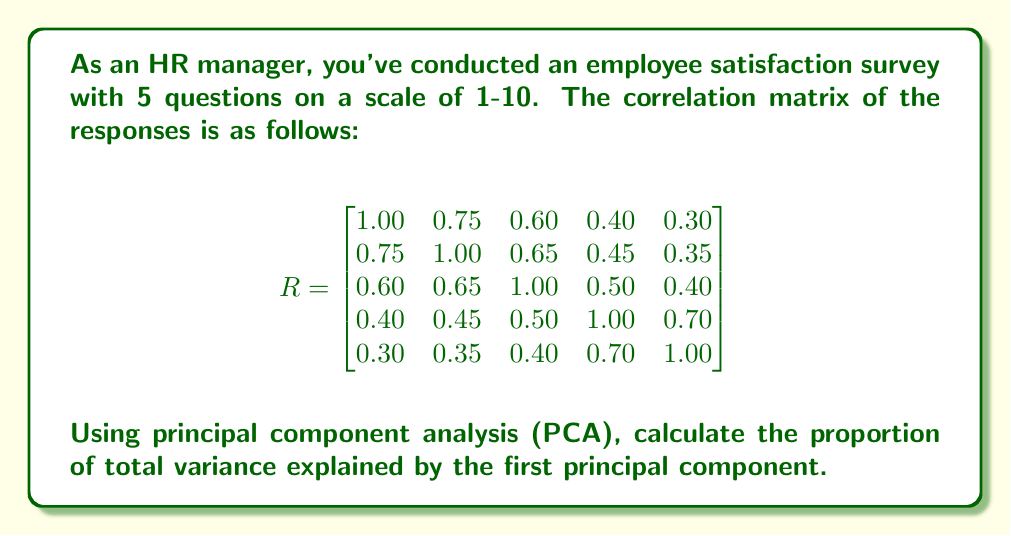Show me your answer to this math problem. To solve this problem, we'll follow these steps:

1) In PCA, the eigenvalues of the correlation matrix represent the variance explained by each principal component.

2) Calculate the eigenvalues of the correlation matrix R. The characteristic equation is:

   $\det(R - \lambda I) = 0$

   Solving this equation gives us the eigenvalues:
   $\lambda_1 = 2.9364, \lambda_2 = 1.0636, \lambda_3 = 0.5000, \lambda_4 = 0.3000, \lambda_5 = 0.2000$

3) The total variance is the sum of all eigenvalues:

   $\text{Total Variance} = \sum_{i=1}^5 \lambda_i = 5$

   This is always equal to the number of variables in a correlation matrix.

4) The proportion of variance explained by the first principal component is:

   $\frac{\lambda_1}{\text{Total Variance}} = \frac{2.9364}{5} = 0.5873$

5) Convert to a percentage: $0.5873 \times 100\% = 58.73\%$

Therefore, the first principal component explains 58.73% of the total variance in the employee satisfaction survey data.
Answer: 58.73% 